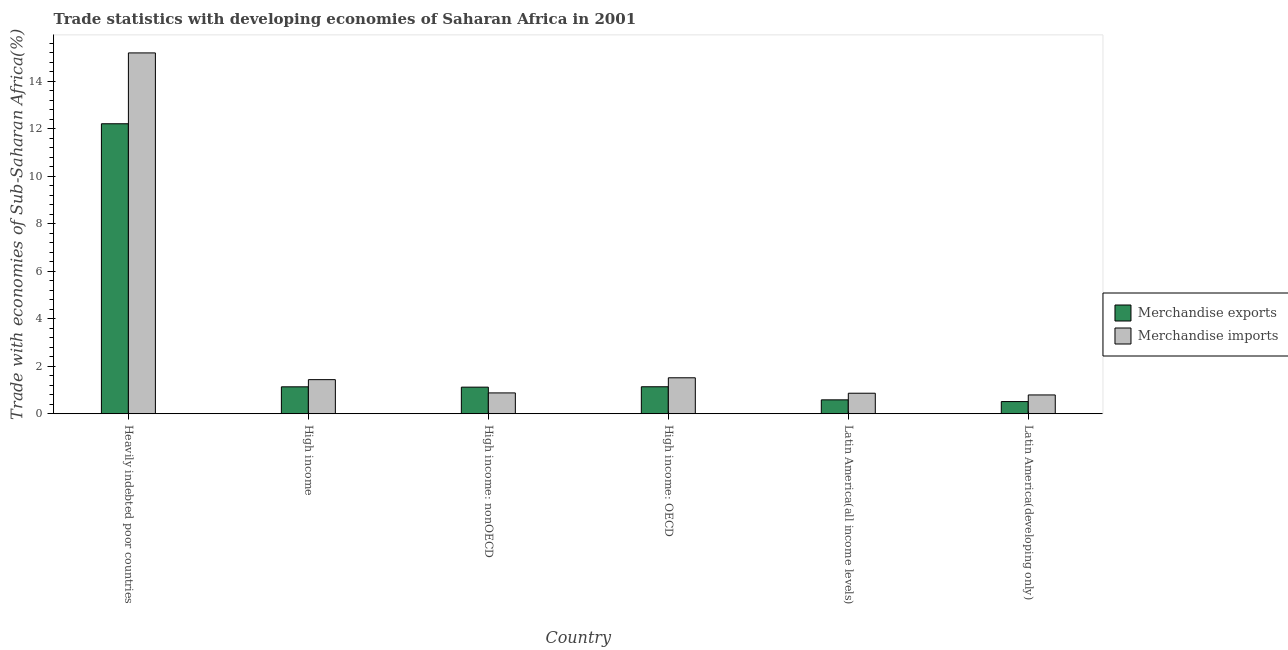How many different coloured bars are there?
Ensure brevity in your answer.  2. How many groups of bars are there?
Offer a terse response. 6. Are the number of bars on each tick of the X-axis equal?
Your response must be concise. Yes. How many bars are there on the 2nd tick from the left?
Your answer should be very brief. 2. What is the label of the 1st group of bars from the left?
Ensure brevity in your answer.  Heavily indebted poor countries. In how many cases, is the number of bars for a given country not equal to the number of legend labels?
Offer a terse response. 0. What is the merchandise imports in High income?
Give a very brief answer. 1.44. Across all countries, what is the maximum merchandise imports?
Your answer should be very brief. 15.19. Across all countries, what is the minimum merchandise imports?
Keep it short and to the point. 0.79. In which country was the merchandise imports maximum?
Your answer should be compact. Heavily indebted poor countries. In which country was the merchandise exports minimum?
Offer a terse response. Latin America(developing only). What is the total merchandise exports in the graph?
Offer a very short reply. 16.7. What is the difference between the merchandise exports in Heavily indebted poor countries and that in High income?
Make the answer very short. 11.08. What is the difference between the merchandise exports in High income: OECD and the merchandise imports in Heavily indebted poor countries?
Offer a very short reply. -14.06. What is the average merchandise exports per country?
Provide a succinct answer. 2.78. What is the difference between the merchandise exports and merchandise imports in Heavily indebted poor countries?
Offer a very short reply. -2.98. In how many countries, is the merchandise imports greater than 4.4 %?
Offer a terse response. 1. What is the ratio of the merchandise exports in High income: nonOECD to that in Latin America(developing only)?
Ensure brevity in your answer.  2.19. What is the difference between the highest and the second highest merchandise exports?
Provide a succinct answer. 11.07. What is the difference between the highest and the lowest merchandise exports?
Your answer should be very brief. 11.7. In how many countries, is the merchandise exports greater than the average merchandise exports taken over all countries?
Make the answer very short. 1. Is the sum of the merchandise imports in Latin America(all income levels) and Latin America(developing only) greater than the maximum merchandise exports across all countries?
Make the answer very short. No. What does the 1st bar from the right in Latin America(developing only) represents?
Your answer should be very brief. Merchandise imports. How many bars are there?
Offer a very short reply. 12. Are all the bars in the graph horizontal?
Offer a very short reply. No. How many countries are there in the graph?
Ensure brevity in your answer.  6. What is the title of the graph?
Provide a succinct answer. Trade statistics with developing economies of Saharan Africa in 2001. What is the label or title of the Y-axis?
Give a very brief answer. Trade with economies of Sub-Saharan Africa(%). What is the Trade with economies of Sub-Saharan Africa(%) in Merchandise exports in Heavily indebted poor countries?
Keep it short and to the point. 12.21. What is the Trade with economies of Sub-Saharan Africa(%) in Merchandise imports in Heavily indebted poor countries?
Ensure brevity in your answer.  15.19. What is the Trade with economies of Sub-Saharan Africa(%) of Merchandise exports in High income?
Keep it short and to the point. 1.13. What is the Trade with economies of Sub-Saharan Africa(%) of Merchandise imports in High income?
Your response must be concise. 1.44. What is the Trade with economies of Sub-Saharan Africa(%) in Merchandise exports in High income: nonOECD?
Provide a short and direct response. 1.12. What is the Trade with economies of Sub-Saharan Africa(%) of Merchandise imports in High income: nonOECD?
Keep it short and to the point. 0.88. What is the Trade with economies of Sub-Saharan Africa(%) in Merchandise exports in High income: OECD?
Your answer should be very brief. 1.14. What is the Trade with economies of Sub-Saharan Africa(%) of Merchandise imports in High income: OECD?
Your answer should be very brief. 1.51. What is the Trade with economies of Sub-Saharan Africa(%) of Merchandise exports in Latin America(all income levels)?
Give a very brief answer. 0.58. What is the Trade with economies of Sub-Saharan Africa(%) of Merchandise imports in Latin America(all income levels)?
Provide a succinct answer. 0.86. What is the Trade with economies of Sub-Saharan Africa(%) of Merchandise exports in Latin America(developing only)?
Provide a short and direct response. 0.51. What is the Trade with economies of Sub-Saharan Africa(%) of Merchandise imports in Latin America(developing only)?
Provide a succinct answer. 0.79. Across all countries, what is the maximum Trade with economies of Sub-Saharan Africa(%) in Merchandise exports?
Your response must be concise. 12.21. Across all countries, what is the maximum Trade with economies of Sub-Saharan Africa(%) in Merchandise imports?
Your answer should be very brief. 15.19. Across all countries, what is the minimum Trade with economies of Sub-Saharan Africa(%) of Merchandise exports?
Keep it short and to the point. 0.51. Across all countries, what is the minimum Trade with economies of Sub-Saharan Africa(%) of Merchandise imports?
Offer a very short reply. 0.79. What is the total Trade with economies of Sub-Saharan Africa(%) of Merchandise exports in the graph?
Give a very brief answer. 16.7. What is the total Trade with economies of Sub-Saharan Africa(%) of Merchandise imports in the graph?
Give a very brief answer. 20.67. What is the difference between the Trade with economies of Sub-Saharan Africa(%) in Merchandise exports in Heavily indebted poor countries and that in High income?
Ensure brevity in your answer.  11.08. What is the difference between the Trade with economies of Sub-Saharan Africa(%) of Merchandise imports in Heavily indebted poor countries and that in High income?
Your answer should be very brief. 13.76. What is the difference between the Trade with economies of Sub-Saharan Africa(%) of Merchandise exports in Heavily indebted poor countries and that in High income: nonOECD?
Provide a succinct answer. 11.09. What is the difference between the Trade with economies of Sub-Saharan Africa(%) in Merchandise imports in Heavily indebted poor countries and that in High income: nonOECD?
Keep it short and to the point. 14.32. What is the difference between the Trade with economies of Sub-Saharan Africa(%) of Merchandise exports in Heavily indebted poor countries and that in High income: OECD?
Make the answer very short. 11.07. What is the difference between the Trade with economies of Sub-Saharan Africa(%) of Merchandise imports in Heavily indebted poor countries and that in High income: OECD?
Offer a very short reply. 13.68. What is the difference between the Trade with economies of Sub-Saharan Africa(%) of Merchandise exports in Heavily indebted poor countries and that in Latin America(all income levels)?
Provide a short and direct response. 11.63. What is the difference between the Trade with economies of Sub-Saharan Africa(%) of Merchandise imports in Heavily indebted poor countries and that in Latin America(all income levels)?
Your response must be concise. 14.33. What is the difference between the Trade with economies of Sub-Saharan Africa(%) of Merchandise exports in Heavily indebted poor countries and that in Latin America(developing only)?
Ensure brevity in your answer.  11.7. What is the difference between the Trade with economies of Sub-Saharan Africa(%) of Merchandise imports in Heavily indebted poor countries and that in Latin America(developing only)?
Your answer should be compact. 14.4. What is the difference between the Trade with economies of Sub-Saharan Africa(%) of Merchandise exports in High income and that in High income: nonOECD?
Ensure brevity in your answer.  0.01. What is the difference between the Trade with economies of Sub-Saharan Africa(%) of Merchandise imports in High income and that in High income: nonOECD?
Offer a terse response. 0.56. What is the difference between the Trade with economies of Sub-Saharan Africa(%) of Merchandise exports in High income and that in High income: OECD?
Provide a succinct answer. -0. What is the difference between the Trade with economies of Sub-Saharan Africa(%) in Merchandise imports in High income and that in High income: OECD?
Keep it short and to the point. -0.08. What is the difference between the Trade with economies of Sub-Saharan Africa(%) of Merchandise exports in High income and that in Latin America(all income levels)?
Provide a short and direct response. 0.55. What is the difference between the Trade with economies of Sub-Saharan Africa(%) in Merchandise imports in High income and that in Latin America(all income levels)?
Your answer should be very brief. 0.57. What is the difference between the Trade with economies of Sub-Saharan Africa(%) of Merchandise exports in High income and that in Latin America(developing only)?
Offer a very short reply. 0.62. What is the difference between the Trade with economies of Sub-Saharan Africa(%) of Merchandise imports in High income and that in Latin America(developing only)?
Ensure brevity in your answer.  0.64. What is the difference between the Trade with economies of Sub-Saharan Africa(%) of Merchandise exports in High income: nonOECD and that in High income: OECD?
Make the answer very short. -0.02. What is the difference between the Trade with economies of Sub-Saharan Africa(%) of Merchandise imports in High income: nonOECD and that in High income: OECD?
Make the answer very short. -0.64. What is the difference between the Trade with economies of Sub-Saharan Africa(%) in Merchandise exports in High income: nonOECD and that in Latin America(all income levels)?
Keep it short and to the point. 0.53. What is the difference between the Trade with economies of Sub-Saharan Africa(%) in Merchandise imports in High income: nonOECD and that in Latin America(all income levels)?
Make the answer very short. 0.01. What is the difference between the Trade with economies of Sub-Saharan Africa(%) in Merchandise exports in High income: nonOECD and that in Latin America(developing only)?
Provide a succinct answer. 0.61. What is the difference between the Trade with economies of Sub-Saharan Africa(%) of Merchandise imports in High income: nonOECD and that in Latin America(developing only)?
Give a very brief answer. 0.09. What is the difference between the Trade with economies of Sub-Saharan Africa(%) in Merchandise exports in High income: OECD and that in Latin America(all income levels)?
Your answer should be compact. 0.55. What is the difference between the Trade with economies of Sub-Saharan Africa(%) of Merchandise imports in High income: OECD and that in Latin America(all income levels)?
Provide a succinct answer. 0.65. What is the difference between the Trade with economies of Sub-Saharan Africa(%) of Merchandise exports in High income: OECD and that in Latin America(developing only)?
Your response must be concise. 0.62. What is the difference between the Trade with economies of Sub-Saharan Africa(%) of Merchandise imports in High income: OECD and that in Latin America(developing only)?
Provide a succinct answer. 0.72. What is the difference between the Trade with economies of Sub-Saharan Africa(%) in Merchandise exports in Latin America(all income levels) and that in Latin America(developing only)?
Offer a very short reply. 0.07. What is the difference between the Trade with economies of Sub-Saharan Africa(%) in Merchandise imports in Latin America(all income levels) and that in Latin America(developing only)?
Your answer should be compact. 0.07. What is the difference between the Trade with economies of Sub-Saharan Africa(%) of Merchandise exports in Heavily indebted poor countries and the Trade with economies of Sub-Saharan Africa(%) of Merchandise imports in High income?
Keep it short and to the point. 10.77. What is the difference between the Trade with economies of Sub-Saharan Africa(%) of Merchandise exports in Heavily indebted poor countries and the Trade with economies of Sub-Saharan Africa(%) of Merchandise imports in High income: nonOECD?
Provide a short and direct response. 11.33. What is the difference between the Trade with economies of Sub-Saharan Africa(%) in Merchandise exports in Heavily indebted poor countries and the Trade with economies of Sub-Saharan Africa(%) in Merchandise imports in High income: OECD?
Offer a terse response. 10.7. What is the difference between the Trade with economies of Sub-Saharan Africa(%) in Merchandise exports in Heavily indebted poor countries and the Trade with economies of Sub-Saharan Africa(%) in Merchandise imports in Latin America(all income levels)?
Offer a very short reply. 11.35. What is the difference between the Trade with economies of Sub-Saharan Africa(%) of Merchandise exports in Heavily indebted poor countries and the Trade with economies of Sub-Saharan Africa(%) of Merchandise imports in Latin America(developing only)?
Keep it short and to the point. 11.42. What is the difference between the Trade with economies of Sub-Saharan Africa(%) in Merchandise exports in High income and the Trade with economies of Sub-Saharan Africa(%) in Merchandise imports in High income: nonOECD?
Ensure brevity in your answer.  0.26. What is the difference between the Trade with economies of Sub-Saharan Africa(%) in Merchandise exports in High income and the Trade with economies of Sub-Saharan Africa(%) in Merchandise imports in High income: OECD?
Make the answer very short. -0.38. What is the difference between the Trade with economies of Sub-Saharan Africa(%) of Merchandise exports in High income and the Trade with economies of Sub-Saharan Africa(%) of Merchandise imports in Latin America(all income levels)?
Your answer should be very brief. 0.27. What is the difference between the Trade with economies of Sub-Saharan Africa(%) in Merchandise exports in High income and the Trade with economies of Sub-Saharan Africa(%) in Merchandise imports in Latin America(developing only)?
Give a very brief answer. 0.34. What is the difference between the Trade with economies of Sub-Saharan Africa(%) in Merchandise exports in High income: nonOECD and the Trade with economies of Sub-Saharan Africa(%) in Merchandise imports in High income: OECD?
Provide a short and direct response. -0.39. What is the difference between the Trade with economies of Sub-Saharan Africa(%) of Merchandise exports in High income: nonOECD and the Trade with economies of Sub-Saharan Africa(%) of Merchandise imports in Latin America(all income levels)?
Provide a succinct answer. 0.26. What is the difference between the Trade with economies of Sub-Saharan Africa(%) of Merchandise exports in High income: nonOECD and the Trade with economies of Sub-Saharan Africa(%) of Merchandise imports in Latin America(developing only)?
Your answer should be compact. 0.33. What is the difference between the Trade with economies of Sub-Saharan Africa(%) of Merchandise exports in High income: OECD and the Trade with economies of Sub-Saharan Africa(%) of Merchandise imports in Latin America(all income levels)?
Provide a succinct answer. 0.27. What is the difference between the Trade with economies of Sub-Saharan Africa(%) in Merchandise exports in High income: OECD and the Trade with economies of Sub-Saharan Africa(%) in Merchandise imports in Latin America(developing only)?
Offer a very short reply. 0.34. What is the difference between the Trade with economies of Sub-Saharan Africa(%) in Merchandise exports in Latin America(all income levels) and the Trade with economies of Sub-Saharan Africa(%) in Merchandise imports in Latin America(developing only)?
Ensure brevity in your answer.  -0.21. What is the average Trade with economies of Sub-Saharan Africa(%) of Merchandise exports per country?
Keep it short and to the point. 2.78. What is the average Trade with economies of Sub-Saharan Africa(%) of Merchandise imports per country?
Provide a succinct answer. 3.45. What is the difference between the Trade with economies of Sub-Saharan Africa(%) of Merchandise exports and Trade with economies of Sub-Saharan Africa(%) of Merchandise imports in Heavily indebted poor countries?
Keep it short and to the point. -2.98. What is the difference between the Trade with economies of Sub-Saharan Africa(%) in Merchandise exports and Trade with economies of Sub-Saharan Africa(%) in Merchandise imports in High income?
Make the answer very short. -0.3. What is the difference between the Trade with economies of Sub-Saharan Africa(%) of Merchandise exports and Trade with economies of Sub-Saharan Africa(%) of Merchandise imports in High income: nonOECD?
Keep it short and to the point. 0.24. What is the difference between the Trade with economies of Sub-Saharan Africa(%) in Merchandise exports and Trade with economies of Sub-Saharan Africa(%) in Merchandise imports in High income: OECD?
Your response must be concise. -0.38. What is the difference between the Trade with economies of Sub-Saharan Africa(%) of Merchandise exports and Trade with economies of Sub-Saharan Africa(%) of Merchandise imports in Latin America(all income levels)?
Provide a short and direct response. -0.28. What is the difference between the Trade with economies of Sub-Saharan Africa(%) of Merchandise exports and Trade with economies of Sub-Saharan Africa(%) of Merchandise imports in Latin America(developing only)?
Offer a terse response. -0.28. What is the ratio of the Trade with economies of Sub-Saharan Africa(%) in Merchandise exports in Heavily indebted poor countries to that in High income?
Ensure brevity in your answer.  10.77. What is the ratio of the Trade with economies of Sub-Saharan Africa(%) of Merchandise imports in Heavily indebted poor countries to that in High income?
Your answer should be compact. 10.58. What is the ratio of the Trade with economies of Sub-Saharan Africa(%) in Merchandise exports in Heavily indebted poor countries to that in High income: nonOECD?
Provide a succinct answer. 10.91. What is the ratio of the Trade with economies of Sub-Saharan Africa(%) in Merchandise imports in Heavily indebted poor countries to that in High income: nonOECD?
Provide a succinct answer. 17.33. What is the ratio of the Trade with economies of Sub-Saharan Africa(%) of Merchandise exports in Heavily indebted poor countries to that in High income: OECD?
Offer a very short reply. 10.75. What is the ratio of the Trade with economies of Sub-Saharan Africa(%) in Merchandise imports in Heavily indebted poor countries to that in High income: OECD?
Ensure brevity in your answer.  10.04. What is the ratio of the Trade with economies of Sub-Saharan Africa(%) in Merchandise exports in Heavily indebted poor countries to that in Latin America(all income levels)?
Provide a succinct answer. 20.88. What is the ratio of the Trade with economies of Sub-Saharan Africa(%) of Merchandise imports in Heavily indebted poor countries to that in Latin America(all income levels)?
Your answer should be very brief. 17.59. What is the ratio of the Trade with economies of Sub-Saharan Africa(%) of Merchandise exports in Heavily indebted poor countries to that in Latin America(developing only)?
Make the answer very short. 23.84. What is the ratio of the Trade with economies of Sub-Saharan Africa(%) of Merchandise imports in Heavily indebted poor countries to that in Latin America(developing only)?
Your response must be concise. 19.2. What is the ratio of the Trade with economies of Sub-Saharan Africa(%) in Merchandise exports in High income to that in High income: nonOECD?
Ensure brevity in your answer.  1.01. What is the ratio of the Trade with economies of Sub-Saharan Africa(%) of Merchandise imports in High income to that in High income: nonOECD?
Provide a short and direct response. 1.64. What is the ratio of the Trade with economies of Sub-Saharan Africa(%) of Merchandise exports in High income to that in High income: OECD?
Your answer should be very brief. 1. What is the ratio of the Trade with economies of Sub-Saharan Africa(%) in Merchandise imports in High income to that in High income: OECD?
Offer a very short reply. 0.95. What is the ratio of the Trade with economies of Sub-Saharan Africa(%) in Merchandise exports in High income to that in Latin America(all income levels)?
Your answer should be very brief. 1.94. What is the ratio of the Trade with economies of Sub-Saharan Africa(%) of Merchandise imports in High income to that in Latin America(all income levels)?
Your answer should be very brief. 1.66. What is the ratio of the Trade with economies of Sub-Saharan Africa(%) of Merchandise exports in High income to that in Latin America(developing only)?
Make the answer very short. 2.21. What is the ratio of the Trade with economies of Sub-Saharan Africa(%) of Merchandise imports in High income to that in Latin America(developing only)?
Ensure brevity in your answer.  1.81. What is the ratio of the Trade with economies of Sub-Saharan Africa(%) of Merchandise exports in High income: nonOECD to that in High income: OECD?
Provide a short and direct response. 0.99. What is the ratio of the Trade with economies of Sub-Saharan Africa(%) in Merchandise imports in High income: nonOECD to that in High income: OECD?
Your response must be concise. 0.58. What is the ratio of the Trade with economies of Sub-Saharan Africa(%) in Merchandise exports in High income: nonOECD to that in Latin America(all income levels)?
Provide a succinct answer. 1.91. What is the ratio of the Trade with economies of Sub-Saharan Africa(%) in Merchandise exports in High income: nonOECD to that in Latin America(developing only)?
Offer a very short reply. 2.19. What is the ratio of the Trade with economies of Sub-Saharan Africa(%) in Merchandise imports in High income: nonOECD to that in Latin America(developing only)?
Provide a succinct answer. 1.11. What is the ratio of the Trade with economies of Sub-Saharan Africa(%) in Merchandise exports in High income: OECD to that in Latin America(all income levels)?
Give a very brief answer. 1.94. What is the ratio of the Trade with economies of Sub-Saharan Africa(%) in Merchandise imports in High income: OECD to that in Latin America(all income levels)?
Provide a succinct answer. 1.75. What is the ratio of the Trade with economies of Sub-Saharan Africa(%) of Merchandise exports in High income: OECD to that in Latin America(developing only)?
Provide a short and direct response. 2.22. What is the ratio of the Trade with economies of Sub-Saharan Africa(%) in Merchandise imports in High income: OECD to that in Latin America(developing only)?
Your answer should be compact. 1.91. What is the ratio of the Trade with economies of Sub-Saharan Africa(%) in Merchandise exports in Latin America(all income levels) to that in Latin America(developing only)?
Provide a short and direct response. 1.14. What is the ratio of the Trade with economies of Sub-Saharan Africa(%) of Merchandise imports in Latin America(all income levels) to that in Latin America(developing only)?
Give a very brief answer. 1.09. What is the difference between the highest and the second highest Trade with economies of Sub-Saharan Africa(%) of Merchandise exports?
Provide a short and direct response. 11.07. What is the difference between the highest and the second highest Trade with economies of Sub-Saharan Africa(%) in Merchandise imports?
Provide a succinct answer. 13.68. What is the difference between the highest and the lowest Trade with economies of Sub-Saharan Africa(%) in Merchandise exports?
Provide a short and direct response. 11.7. What is the difference between the highest and the lowest Trade with economies of Sub-Saharan Africa(%) in Merchandise imports?
Offer a very short reply. 14.4. 